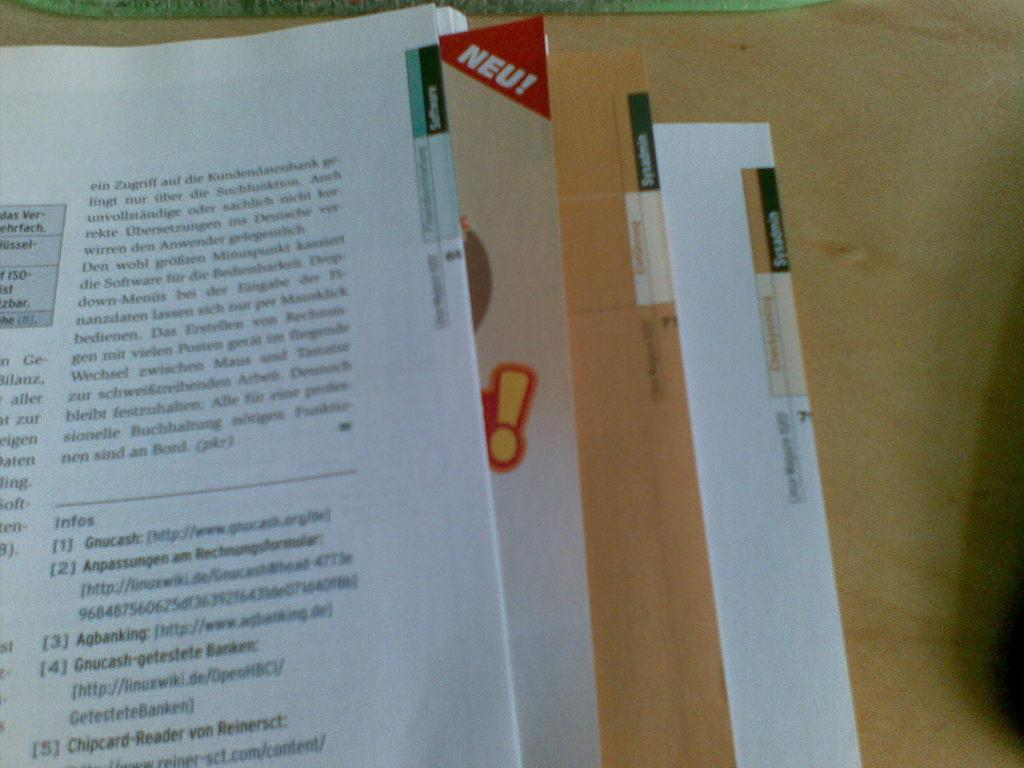Provide a one-sentence caption for the provided image. a  book is open and has a bookmark that has the word Neu! on it. 